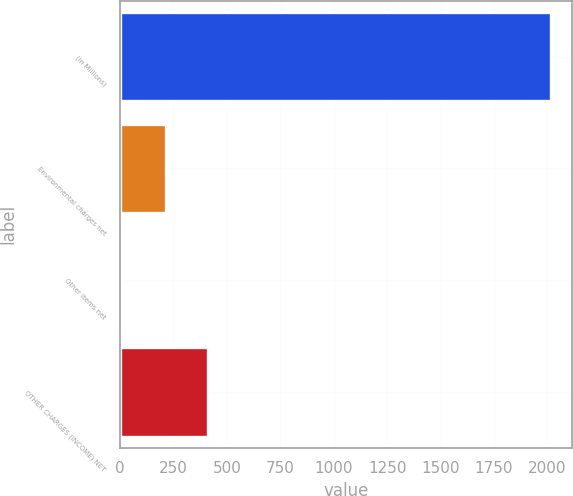<chart> <loc_0><loc_0><loc_500><loc_500><bar_chart><fcel>(in Millions)<fcel>Environmental charges net<fcel>Other items net<fcel>OTHER CHARGES (INCOME) NET<nl><fcel>2016<fcel>213.21<fcel>12.9<fcel>413.52<nl></chart> 